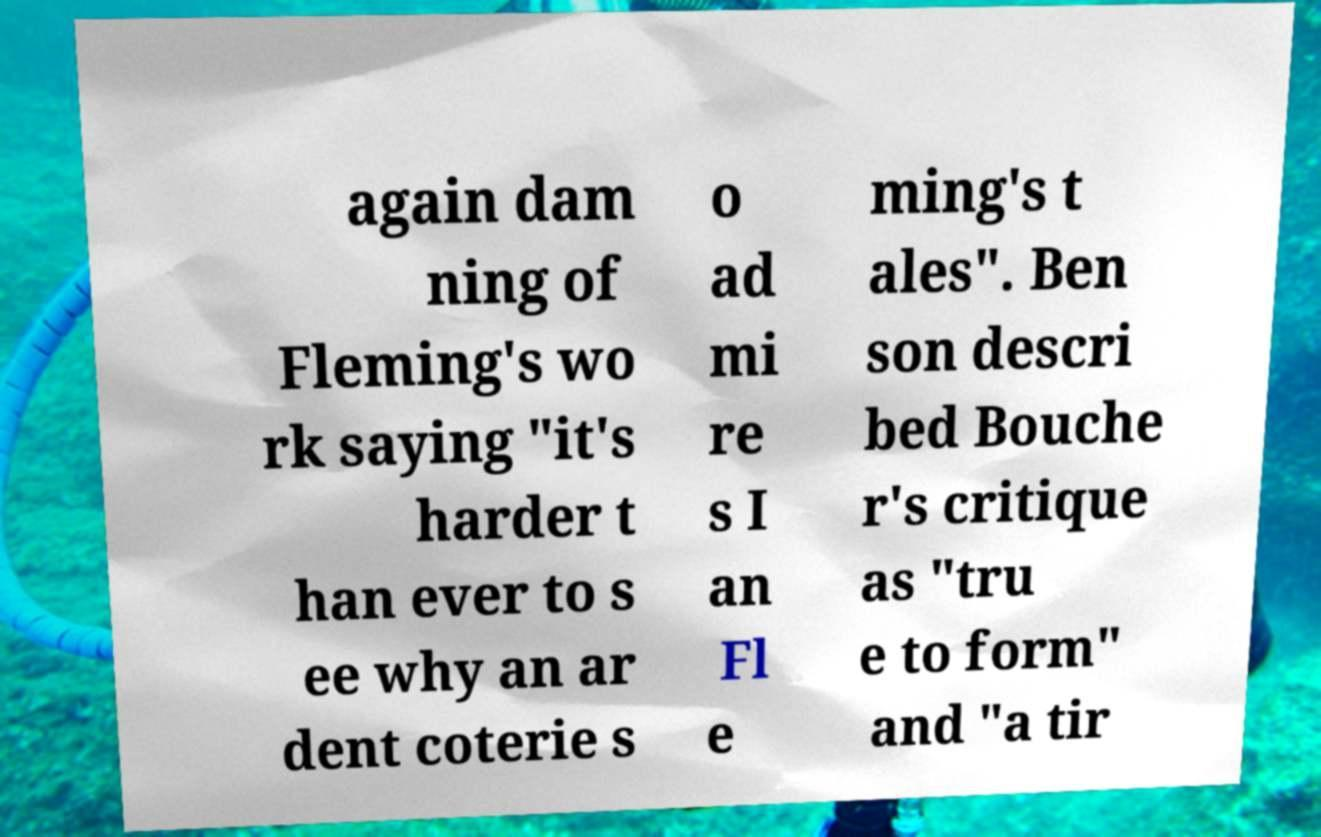For documentation purposes, I need the text within this image transcribed. Could you provide that? again dam ning of Fleming's wo rk saying "it's harder t han ever to s ee why an ar dent coterie s o ad mi re s I an Fl e ming's t ales". Ben son descri bed Bouche r's critique as "tru e to form" and "a tir 